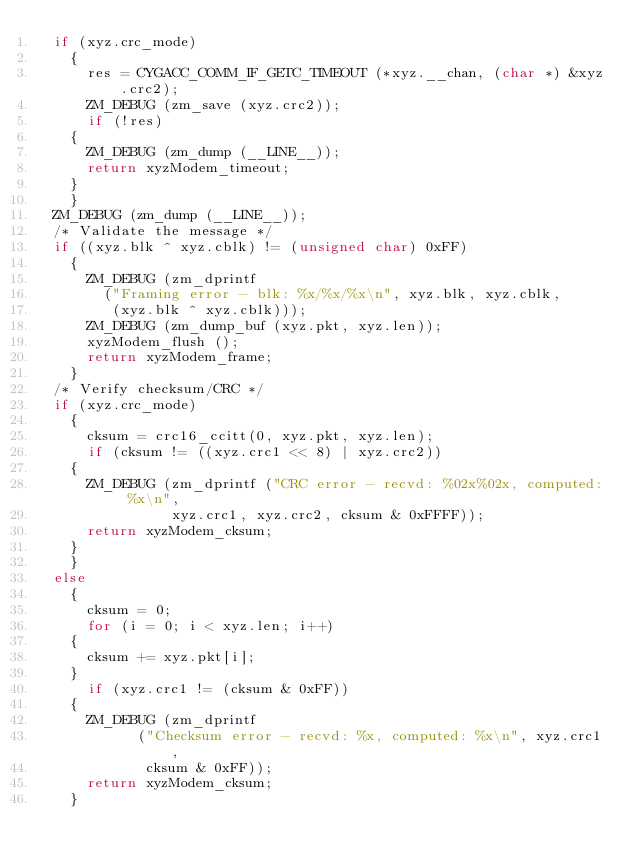<code> <loc_0><loc_0><loc_500><loc_500><_C_>  if (xyz.crc_mode)
    {
      res = CYGACC_COMM_IF_GETC_TIMEOUT (*xyz.__chan, (char *) &xyz.crc2);
      ZM_DEBUG (zm_save (xyz.crc2));
      if (!res)
	{
	  ZM_DEBUG (zm_dump (__LINE__));
	  return xyzModem_timeout;
	}
    }
  ZM_DEBUG (zm_dump (__LINE__));
  /* Validate the message */
  if ((xyz.blk ^ xyz.cblk) != (unsigned char) 0xFF)
    {
      ZM_DEBUG (zm_dprintf
		("Framing error - blk: %x/%x/%x\n", xyz.blk, xyz.cblk,
		 (xyz.blk ^ xyz.cblk)));
      ZM_DEBUG (zm_dump_buf (xyz.pkt, xyz.len));
      xyzModem_flush ();
      return xyzModem_frame;
    }
  /* Verify checksum/CRC */
  if (xyz.crc_mode)
    {
      cksum = crc16_ccitt(0, xyz.pkt, xyz.len);
      if (cksum != ((xyz.crc1 << 8) | xyz.crc2))
	{
	  ZM_DEBUG (zm_dprintf ("CRC error - recvd: %02x%02x, computed: %x\n",
				xyz.crc1, xyz.crc2, cksum & 0xFFFF));
	  return xyzModem_cksum;
	}
    }
  else
    {
      cksum = 0;
      for (i = 0; i < xyz.len; i++)
	{
	  cksum += xyz.pkt[i];
	}
      if (xyz.crc1 != (cksum & 0xFF))
	{
	  ZM_DEBUG (zm_dprintf
		    ("Checksum error - recvd: %x, computed: %x\n", xyz.crc1,
		     cksum & 0xFF));
	  return xyzModem_cksum;
	}</code> 